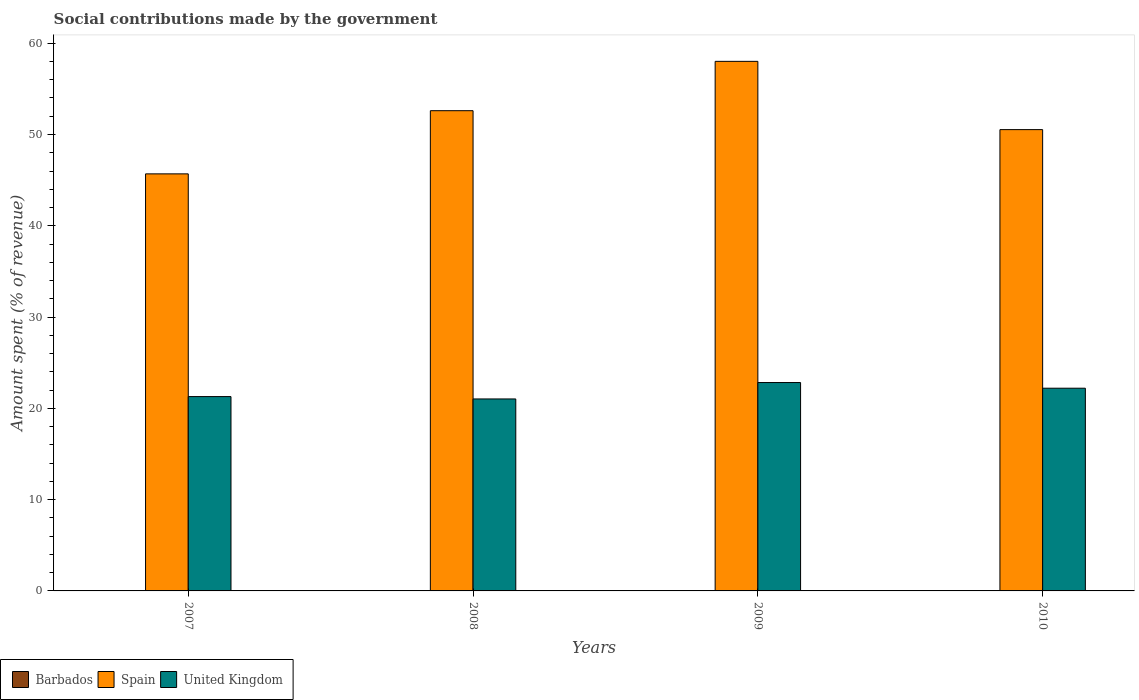How many bars are there on the 2nd tick from the left?
Your response must be concise. 3. What is the amount spent (in %) on social contributions in United Kingdom in 2010?
Your answer should be very brief. 22.21. Across all years, what is the maximum amount spent (in %) on social contributions in Spain?
Your answer should be compact. 58.01. Across all years, what is the minimum amount spent (in %) on social contributions in United Kingdom?
Offer a terse response. 21.03. In which year was the amount spent (in %) on social contributions in Barbados minimum?
Make the answer very short. 2009. What is the total amount spent (in %) on social contributions in Barbados in the graph?
Give a very brief answer. 0.14. What is the difference between the amount spent (in %) on social contributions in United Kingdom in 2008 and that in 2009?
Offer a very short reply. -1.8. What is the difference between the amount spent (in %) on social contributions in Spain in 2007 and the amount spent (in %) on social contributions in United Kingdom in 2009?
Your response must be concise. 22.86. What is the average amount spent (in %) on social contributions in Spain per year?
Give a very brief answer. 51.71. In the year 2007, what is the difference between the amount spent (in %) on social contributions in Barbados and amount spent (in %) on social contributions in United Kingdom?
Give a very brief answer. -21.25. In how many years, is the amount spent (in %) on social contributions in Spain greater than 58 %?
Give a very brief answer. 1. What is the ratio of the amount spent (in %) on social contributions in United Kingdom in 2007 to that in 2008?
Give a very brief answer. 1.01. Is the amount spent (in %) on social contributions in Spain in 2007 less than that in 2009?
Offer a terse response. Yes. Is the difference between the amount spent (in %) on social contributions in Barbados in 2008 and 2010 greater than the difference between the amount spent (in %) on social contributions in United Kingdom in 2008 and 2010?
Give a very brief answer. Yes. What is the difference between the highest and the second highest amount spent (in %) on social contributions in Barbados?
Provide a short and direct response. 0. What is the difference between the highest and the lowest amount spent (in %) on social contributions in Barbados?
Provide a short and direct response. 0.01. Is it the case that in every year, the sum of the amount spent (in %) on social contributions in Barbados and amount spent (in %) on social contributions in United Kingdom is greater than the amount spent (in %) on social contributions in Spain?
Your response must be concise. No. How many bars are there?
Offer a very short reply. 12. What is the difference between two consecutive major ticks on the Y-axis?
Provide a succinct answer. 10. Are the values on the major ticks of Y-axis written in scientific E-notation?
Keep it short and to the point. No. Does the graph contain any zero values?
Your answer should be very brief. No. Where does the legend appear in the graph?
Your answer should be very brief. Bottom left. How many legend labels are there?
Your response must be concise. 3. How are the legend labels stacked?
Your answer should be compact. Horizontal. What is the title of the graph?
Provide a short and direct response. Social contributions made by the government. What is the label or title of the X-axis?
Offer a very short reply. Years. What is the label or title of the Y-axis?
Your response must be concise. Amount spent (% of revenue). What is the Amount spent (% of revenue) of Barbados in 2007?
Ensure brevity in your answer.  0.04. What is the Amount spent (% of revenue) in Spain in 2007?
Provide a succinct answer. 45.69. What is the Amount spent (% of revenue) in United Kingdom in 2007?
Give a very brief answer. 21.29. What is the Amount spent (% of revenue) of Barbados in 2008?
Offer a very short reply. 0.04. What is the Amount spent (% of revenue) of Spain in 2008?
Give a very brief answer. 52.61. What is the Amount spent (% of revenue) in United Kingdom in 2008?
Your response must be concise. 21.03. What is the Amount spent (% of revenue) in Barbados in 2009?
Make the answer very short. 0.03. What is the Amount spent (% of revenue) in Spain in 2009?
Your answer should be very brief. 58.01. What is the Amount spent (% of revenue) in United Kingdom in 2009?
Provide a succinct answer. 22.83. What is the Amount spent (% of revenue) in Barbados in 2010?
Your answer should be compact. 0.03. What is the Amount spent (% of revenue) of Spain in 2010?
Your answer should be compact. 50.53. What is the Amount spent (% of revenue) of United Kingdom in 2010?
Provide a short and direct response. 22.21. Across all years, what is the maximum Amount spent (% of revenue) of Barbados?
Provide a succinct answer. 0.04. Across all years, what is the maximum Amount spent (% of revenue) in Spain?
Offer a very short reply. 58.01. Across all years, what is the maximum Amount spent (% of revenue) of United Kingdom?
Your response must be concise. 22.83. Across all years, what is the minimum Amount spent (% of revenue) of Barbados?
Offer a terse response. 0.03. Across all years, what is the minimum Amount spent (% of revenue) in Spain?
Your response must be concise. 45.69. Across all years, what is the minimum Amount spent (% of revenue) of United Kingdom?
Provide a short and direct response. 21.03. What is the total Amount spent (% of revenue) in Barbados in the graph?
Your response must be concise. 0.14. What is the total Amount spent (% of revenue) of Spain in the graph?
Give a very brief answer. 206.84. What is the total Amount spent (% of revenue) of United Kingdom in the graph?
Make the answer very short. 87.35. What is the difference between the Amount spent (% of revenue) in Barbados in 2007 and that in 2008?
Your answer should be very brief. 0. What is the difference between the Amount spent (% of revenue) of Spain in 2007 and that in 2008?
Keep it short and to the point. -6.92. What is the difference between the Amount spent (% of revenue) in United Kingdom in 2007 and that in 2008?
Keep it short and to the point. 0.26. What is the difference between the Amount spent (% of revenue) in Barbados in 2007 and that in 2009?
Your response must be concise. 0.01. What is the difference between the Amount spent (% of revenue) of Spain in 2007 and that in 2009?
Your answer should be very brief. -12.33. What is the difference between the Amount spent (% of revenue) of United Kingdom in 2007 and that in 2009?
Provide a succinct answer. -1.54. What is the difference between the Amount spent (% of revenue) in Barbados in 2007 and that in 2010?
Provide a succinct answer. 0.01. What is the difference between the Amount spent (% of revenue) in Spain in 2007 and that in 2010?
Ensure brevity in your answer.  -4.85. What is the difference between the Amount spent (% of revenue) of United Kingdom in 2007 and that in 2010?
Make the answer very short. -0.92. What is the difference between the Amount spent (% of revenue) in Barbados in 2008 and that in 2009?
Offer a terse response. 0.01. What is the difference between the Amount spent (% of revenue) in Spain in 2008 and that in 2009?
Provide a short and direct response. -5.4. What is the difference between the Amount spent (% of revenue) in United Kingdom in 2008 and that in 2009?
Offer a terse response. -1.8. What is the difference between the Amount spent (% of revenue) in Barbados in 2008 and that in 2010?
Your answer should be compact. 0. What is the difference between the Amount spent (% of revenue) of Spain in 2008 and that in 2010?
Your response must be concise. 2.07. What is the difference between the Amount spent (% of revenue) of United Kingdom in 2008 and that in 2010?
Ensure brevity in your answer.  -1.18. What is the difference between the Amount spent (% of revenue) in Barbados in 2009 and that in 2010?
Offer a very short reply. -0. What is the difference between the Amount spent (% of revenue) of Spain in 2009 and that in 2010?
Make the answer very short. 7.48. What is the difference between the Amount spent (% of revenue) in United Kingdom in 2009 and that in 2010?
Keep it short and to the point. 0.62. What is the difference between the Amount spent (% of revenue) of Barbados in 2007 and the Amount spent (% of revenue) of Spain in 2008?
Keep it short and to the point. -52.57. What is the difference between the Amount spent (% of revenue) of Barbados in 2007 and the Amount spent (% of revenue) of United Kingdom in 2008?
Your response must be concise. -20.99. What is the difference between the Amount spent (% of revenue) of Spain in 2007 and the Amount spent (% of revenue) of United Kingdom in 2008?
Provide a succinct answer. 24.66. What is the difference between the Amount spent (% of revenue) of Barbados in 2007 and the Amount spent (% of revenue) of Spain in 2009?
Ensure brevity in your answer.  -57.97. What is the difference between the Amount spent (% of revenue) in Barbados in 2007 and the Amount spent (% of revenue) in United Kingdom in 2009?
Offer a very short reply. -22.79. What is the difference between the Amount spent (% of revenue) in Spain in 2007 and the Amount spent (% of revenue) in United Kingdom in 2009?
Make the answer very short. 22.86. What is the difference between the Amount spent (% of revenue) in Barbados in 2007 and the Amount spent (% of revenue) in Spain in 2010?
Your response must be concise. -50.49. What is the difference between the Amount spent (% of revenue) of Barbados in 2007 and the Amount spent (% of revenue) of United Kingdom in 2010?
Your answer should be very brief. -22.17. What is the difference between the Amount spent (% of revenue) of Spain in 2007 and the Amount spent (% of revenue) of United Kingdom in 2010?
Your response must be concise. 23.48. What is the difference between the Amount spent (% of revenue) in Barbados in 2008 and the Amount spent (% of revenue) in Spain in 2009?
Keep it short and to the point. -57.98. What is the difference between the Amount spent (% of revenue) in Barbados in 2008 and the Amount spent (% of revenue) in United Kingdom in 2009?
Ensure brevity in your answer.  -22.79. What is the difference between the Amount spent (% of revenue) in Spain in 2008 and the Amount spent (% of revenue) in United Kingdom in 2009?
Your answer should be very brief. 29.78. What is the difference between the Amount spent (% of revenue) in Barbados in 2008 and the Amount spent (% of revenue) in Spain in 2010?
Provide a succinct answer. -50.5. What is the difference between the Amount spent (% of revenue) of Barbados in 2008 and the Amount spent (% of revenue) of United Kingdom in 2010?
Your response must be concise. -22.17. What is the difference between the Amount spent (% of revenue) in Spain in 2008 and the Amount spent (% of revenue) in United Kingdom in 2010?
Make the answer very short. 30.4. What is the difference between the Amount spent (% of revenue) of Barbados in 2009 and the Amount spent (% of revenue) of Spain in 2010?
Give a very brief answer. -50.5. What is the difference between the Amount spent (% of revenue) of Barbados in 2009 and the Amount spent (% of revenue) of United Kingdom in 2010?
Your response must be concise. -22.18. What is the difference between the Amount spent (% of revenue) of Spain in 2009 and the Amount spent (% of revenue) of United Kingdom in 2010?
Keep it short and to the point. 35.81. What is the average Amount spent (% of revenue) in Barbados per year?
Provide a short and direct response. 0.03. What is the average Amount spent (% of revenue) of Spain per year?
Offer a terse response. 51.71. What is the average Amount spent (% of revenue) in United Kingdom per year?
Offer a terse response. 21.84. In the year 2007, what is the difference between the Amount spent (% of revenue) in Barbados and Amount spent (% of revenue) in Spain?
Make the answer very short. -45.65. In the year 2007, what is the difference between the Amount spent (% of revenue) in Barbados and Amount spent (% of revenue) in United Kingdom?
Ensure brevity in your answer.  -21.25. In the year 2007, what is the difference between the Amount spent (% of revenue) of Spain and Amount spent (% of revenue) of United Kingdom?
Your answer should be very brief. 24.4. In the year 2008, what is the difference between the Amount spent (% of revenue) of Barbados and Amount spent (% of revenue) of Spain?
Your answer should be very brief. -52.57. In the year 2008, what is the difference between the Amount spent (% of revenue) of Barbados and Amount spent (% of revenue) of United Kingdom?
Make the answer very short. -20.99. In the year 2008, what is the difference between the Amount spent (% of revenue) in Spain and Amount spent (% of revenue) in United Kingdom?
Provide a succinct answer. 31.58. In the year 2009, what is the difference between the Amount spent (% of revenue) in Barbados and Amount spent (% of revenue) in Spain?
Make the answer very short. -57.98. In the year 2009, what is the difference between the Amount spent (% of revenue) of Barbados and Amount spent (% of revenue) of United Kingdom?
Your response must be concise. -22.8. In the year 2009, what is the difference between the Amount spent (% of revenue) in Spain and Amount spent (% of revenue) in United Kingdom?
Your answer should be compact. 35.19. In the year 2010, what is the difference between the Amount spent (% of revenue) of Barbados and Amount spent (% of revenue) of Spain?
Give a very brief answer. -50.5. In the year 2010, what is the difference between the Amount spent (% of revenue) in Barbados and Amount spent (% of revenue) in United Kingdom?
Your answer should be very brief. -22.17. In the year 2010, what is the difference between the Amount spent (% of revenue) in Spain and Amount spent (% of revenue) in United Kingdom?
Provide a succinct answer. 28.33. What is the ratio of the Amount spent (% of revenue) in Barbados in 2007 to that in 2008?
Your answer should be compact. 1.12. What is the ratio of the Amount spent (% of revenue) of Spain in 2007 to that in 2008?
Ensure brevity in your answer.  0.87. What is the ratio of the Amount spent (% of revenue) of United Kingdom in 2007 to that in 2008?
Ensure brevity in your answer.  1.01. What is the ratio of the Amount spent (% of revenue) in Barbados in 2007 to that in 2009?
Your answer should be compact. 1.35. What is the ratio of the Amount spent (% of revenue) of Spain in 2007 to that in 2009?
Your answer should be compact. 0.79. What is the ratio of the Amount spent (% of revenue) in United Kingdom in 2007 to that in 2009?
Make the answer very short. 0.93. What is the ratio of the Amount spent (% of revenue) of Barbados in 2007 to that in 2010?
Your response must be concise. 1.25. What is the ratio of the Amount spent (% of revenue) of Spain in 2007 to that in 2010?
Your answer should be very brief. 0.9. What is the ratio of the Amount spent (% of revenue) of United Kingdom in 2007 to that in 2010?
Your answer should be compact. 0.96. What is the ratio of the Amount spent (% of revenue) of Barbados in 2008 to that in 2009?
Provide a succinct answer. 1.21. What is the ratio of the Amount spent (% of revenue) of Spain in 2008 to that in 2009?
Offer a terse response. 0.91. What is the ratio of the Amount spent (% of revenue) in United Kingdom in 2008 to that in 2009?
Offer a very short reply. 0.92. What is the ratio of the Amount spent (% of revenue) of Barbados in 2008 to that in 2010?
Give a very brief answer. 1.12. What is the ratio of the Amount spent (% of revenue) of Spain in 2008 to that in 2010?
Your answer should be compact. 1.04. What is the ratio of the Amount spent (% of revenue) in United Kingdom in 2008 to that in 2010?
Make the answer very short. 0.95. What is the ratio of the Amount spent (% of revenue) in Barbados in 2009 to that in 2010?
Give a very brief answer. 0.92. What is the ratio of the Amount spent (% of revenue) of Spain in 2009 to that in 2010?
Your response must be concise. 1.15. What is the ratio of the Amount spent (% of revenue) in United Kingdom in 2009 to that in 2010?
Your answer should be compact. 1.03. What is the difference between the highest and the second highest Amount spent (% of revenue) of Barbados?
Provide a short and direct response. 0. What is the difference between the highest and the second highest Amount spent (% of revenue) in Spain?
Keep it short and to the point. 5.4. What is the difference between the highest and the second highest Amount spent (% of revenue) in United Kingdom?
Provide a succinct answer. 0.62. What is the difference between the highest and the lowest Amount spent (% of revenue) of Barbados?
Offer a terse response. 0.01. What is the difference between the highest and the lowest Amount spent (% of revenue) in Spain?
Offer a very short reply. 12.33. What is the difference between the highest and the lowest Amount spent (% of revenue) in United Kingdom?
Offer a very short reply. 1.8. 